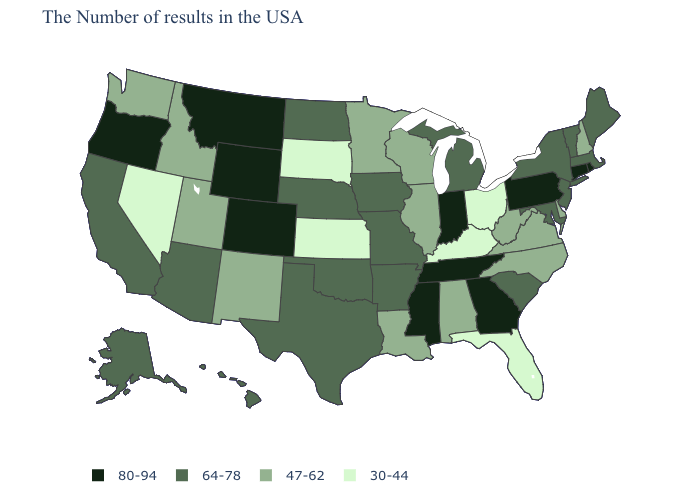Among the states that border Montana , which have the lowest value?
Write a very short answer. South Dakota. Does Georgia have the highest value in the USA?
Quick response, please. Yes. What is the highest value in states that border Minnesota?
Short answer required. 64-78. What is the highest value in the USA?
Concise answer only. 80-94. Name the states that have a value in the range 80-94?
Give a very brief answer. Rhode Island, Connecticut, Pennsylvania, Georgia, Indiana, Tennessee, Mississippi, Wyoming, Colorado, Montana, Oregon. What is the value of Louisiana?
Short answer required. 47-62. Does New Jersey have the same value as Nebraska?
Give a very brief answer. Yes. Does Florida have the lowest value in the USA?
Keep it brief. Yes. What is the highest value in the USA?
Keep it brief. 80-94. Name the states that have a value in the range 64-78?
Keep it brief. Maine, Massachusetts, Vermont, New York, New Jersey, Maryland, South Carolina, Michigan, Missouri, Arkansas, Iowa, Nebraska, Oklahoma, Texas, North Dakota, Arizona, California, Alaska, Hawaii. Which states hav the highest value in the West?
Be succinct. Wyoming, Colorado, Montana, Oregon. Does Nevada have the lowest value in the West?
Answer briefly. Yes. How many symbols are there in the legend?
Keep it brief. 4. Name the states that have a value in the range 80-94?
Quick response, please. Rhode Island, Connecticut, Pennsylvania, Georgia, Indiana, Tennessee, Mississippi, Wyoming, Colorado, Montana, Oregon. 